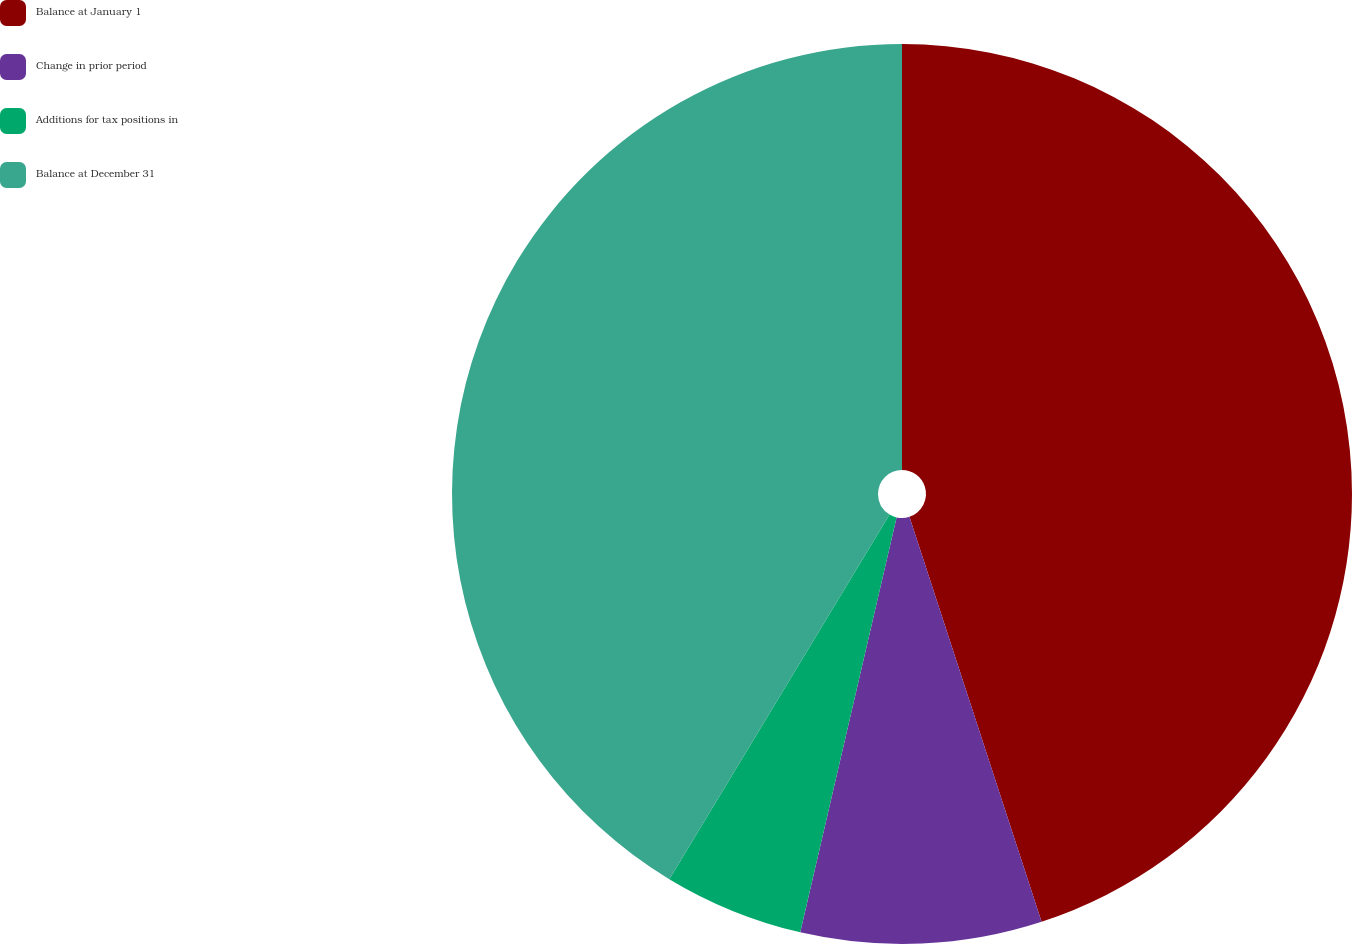Convert chart. <chart><loc_0><loc_0><loc_500><loc_500><pie_chart><fcel>Balance at January 1<fcel>Change in prior period<fcel>Additions for tax positions in<fcel>Balance at December 31<nl><fcel>44.98%<fcel>8.65%<fcel>5.02%<fcel>41.35%<nl></chart> 